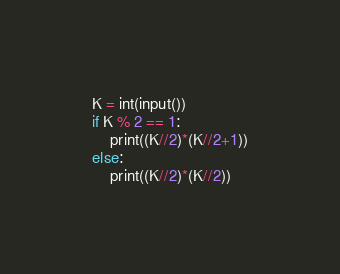Convert code to text. <code><loc_0><loc_0><loc_500><loc_500><_Python_>K = int(input())
if K % 2 == 1:
    print((K//2)*(K//2+1))
else:
    print((K//2)*(K//2))</code> 